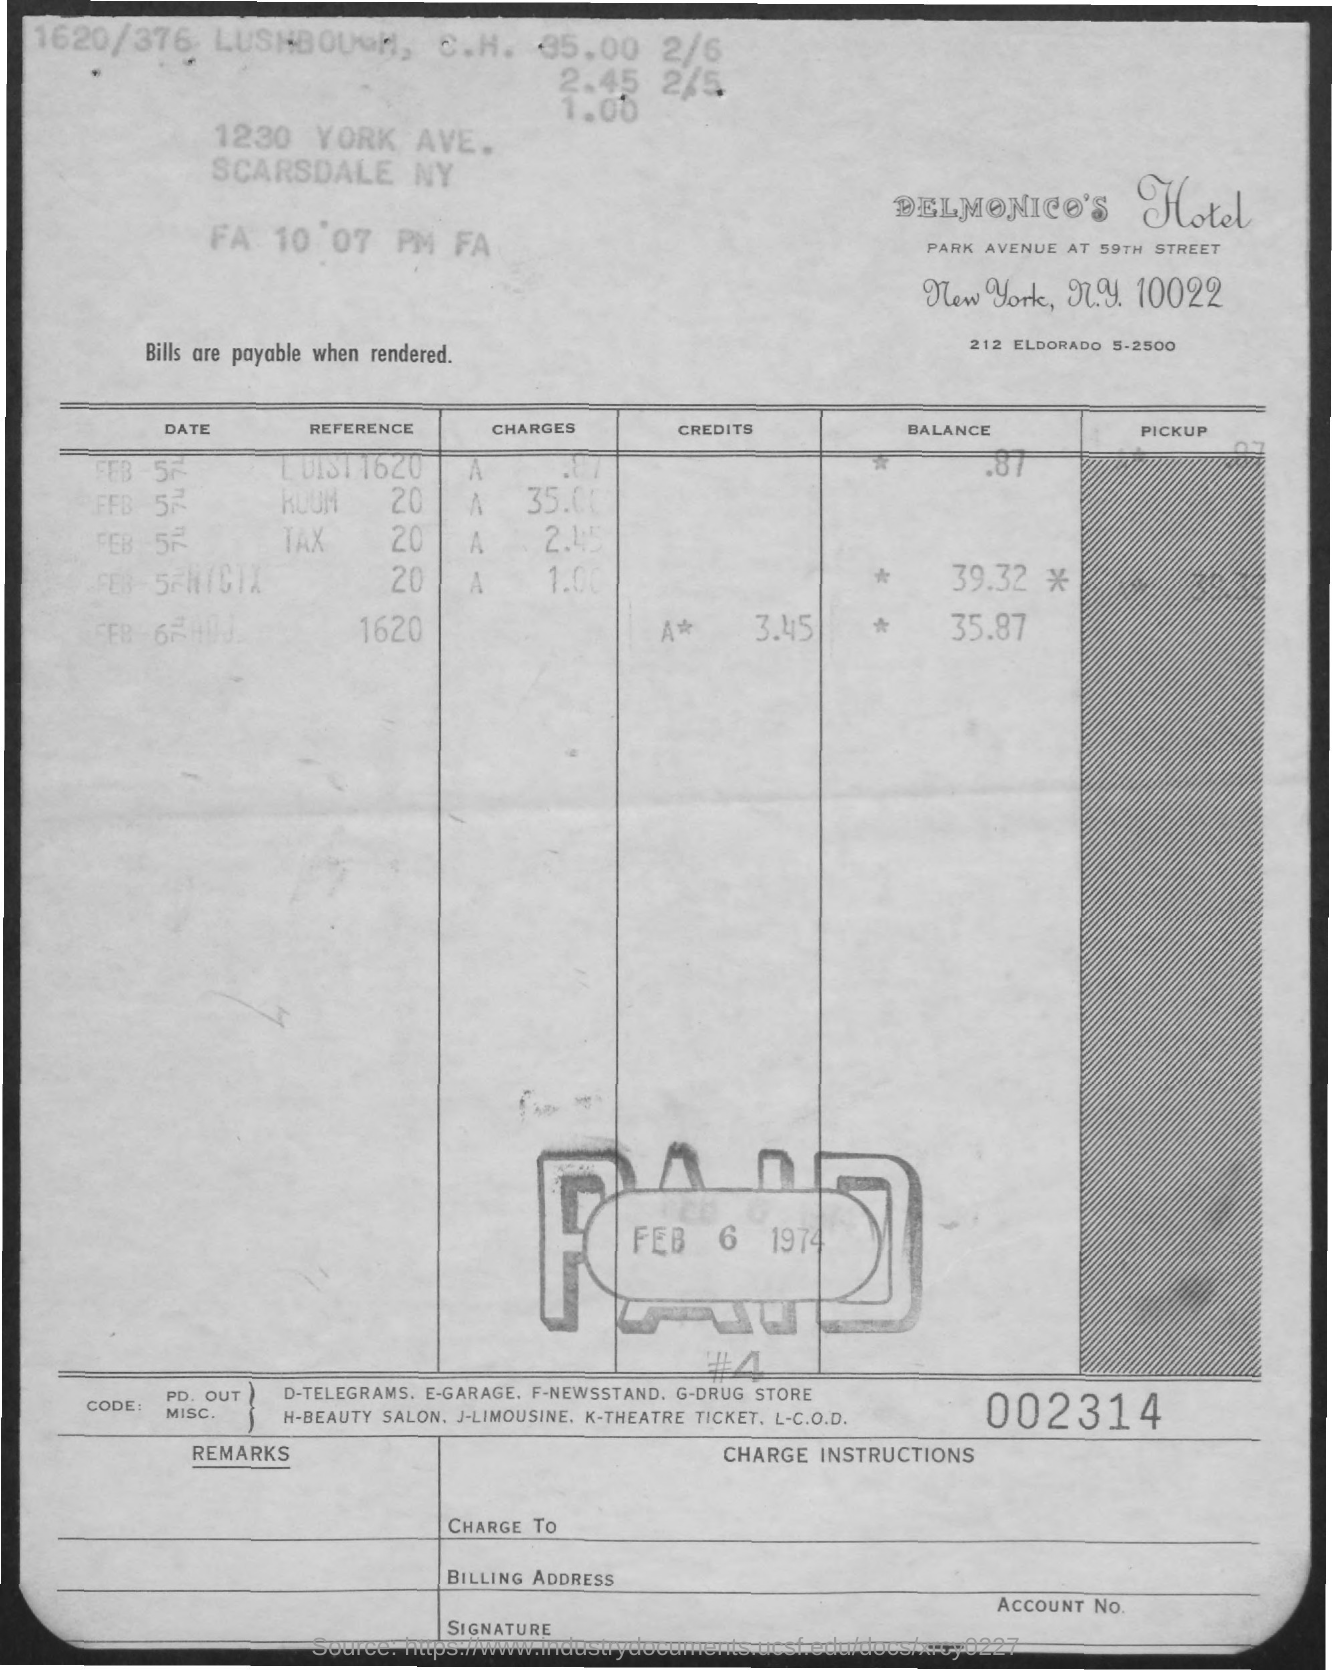What is the name of the hotel?
Your answer should be compact. Delmonico's Hotel. What is the date of the pay?
Your answer should be very brief. Feb 6 1974. What is the 6-digit number at the bottom of the document?
Offer a terse response. 002314. 